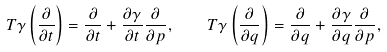<formula> <loc_0><loc_0><loc_500><loc_500>T \gamma \left ( \frac { \partial } { \partial t } \right ) = \frac { \partial } { \partial t } + \frac { \partial \gamma } { \partial t } \frac { \partial } { \partial p } , \quad T \gamma \left ( \frac { \partial } { \partial q } \right ) = \frac { \partial } { \partial q } + \frac { \partial \gamma } { \partial q } \frac { \partial } { \partial p } ,</formula> 